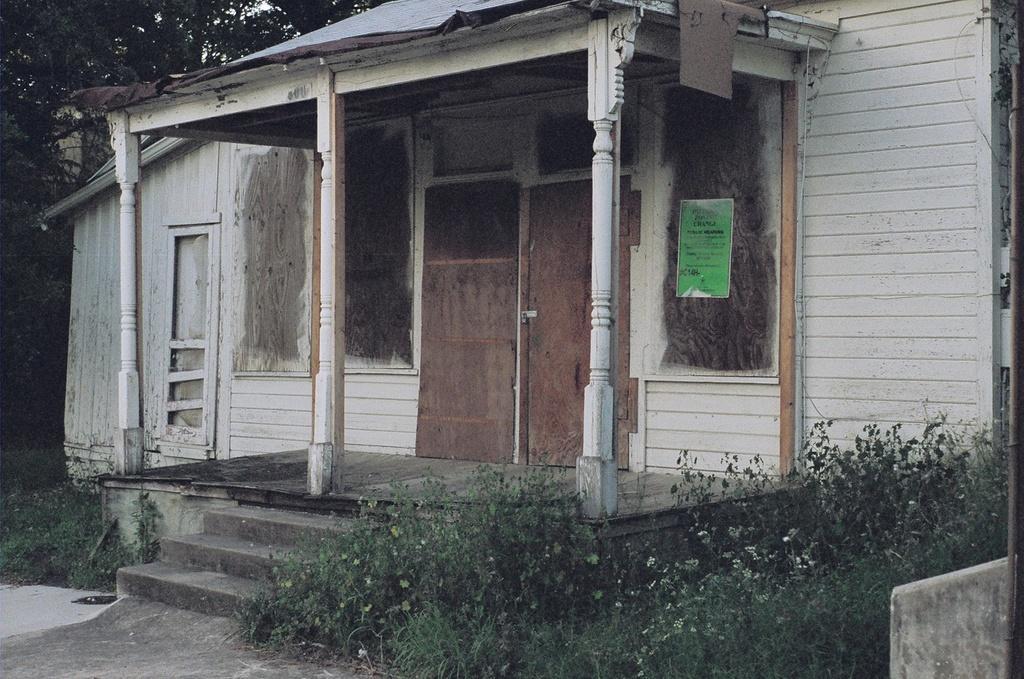In one or two sentences, can you explain what this image depicts? This is a picture of a house. In the center it is a door. In the foreground there are plants, staircase and table. At the top there are trees. 